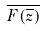<formula> <loc_0><loc_0><loc_500><loc_500>\overline { F ( \overline { z } ) }</formula> 